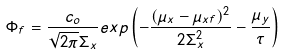<formula> <loc_0><loc_0><loc_500><loc_500>\Phi _ { f } = \frac { c _ { o } } { \sqrt { 2 \pi } \Sigma _ { x } } e x p \left ( - \frac { ( \mu _ { x } - \mu _ { x f } ) ^ { 2 } } { 2 \Sigma _ { x } ^ { 2 } } - \frac { \mu _ { y } } { \tau } \right )</formula> 